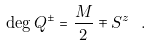Convert formula to latex. <formula><loc_0><loc_0><loc_500><loc_500>\deg Q ^ { \pm } = \frac { M } { 2 } \mp S ^ { z } \ .</formula> 